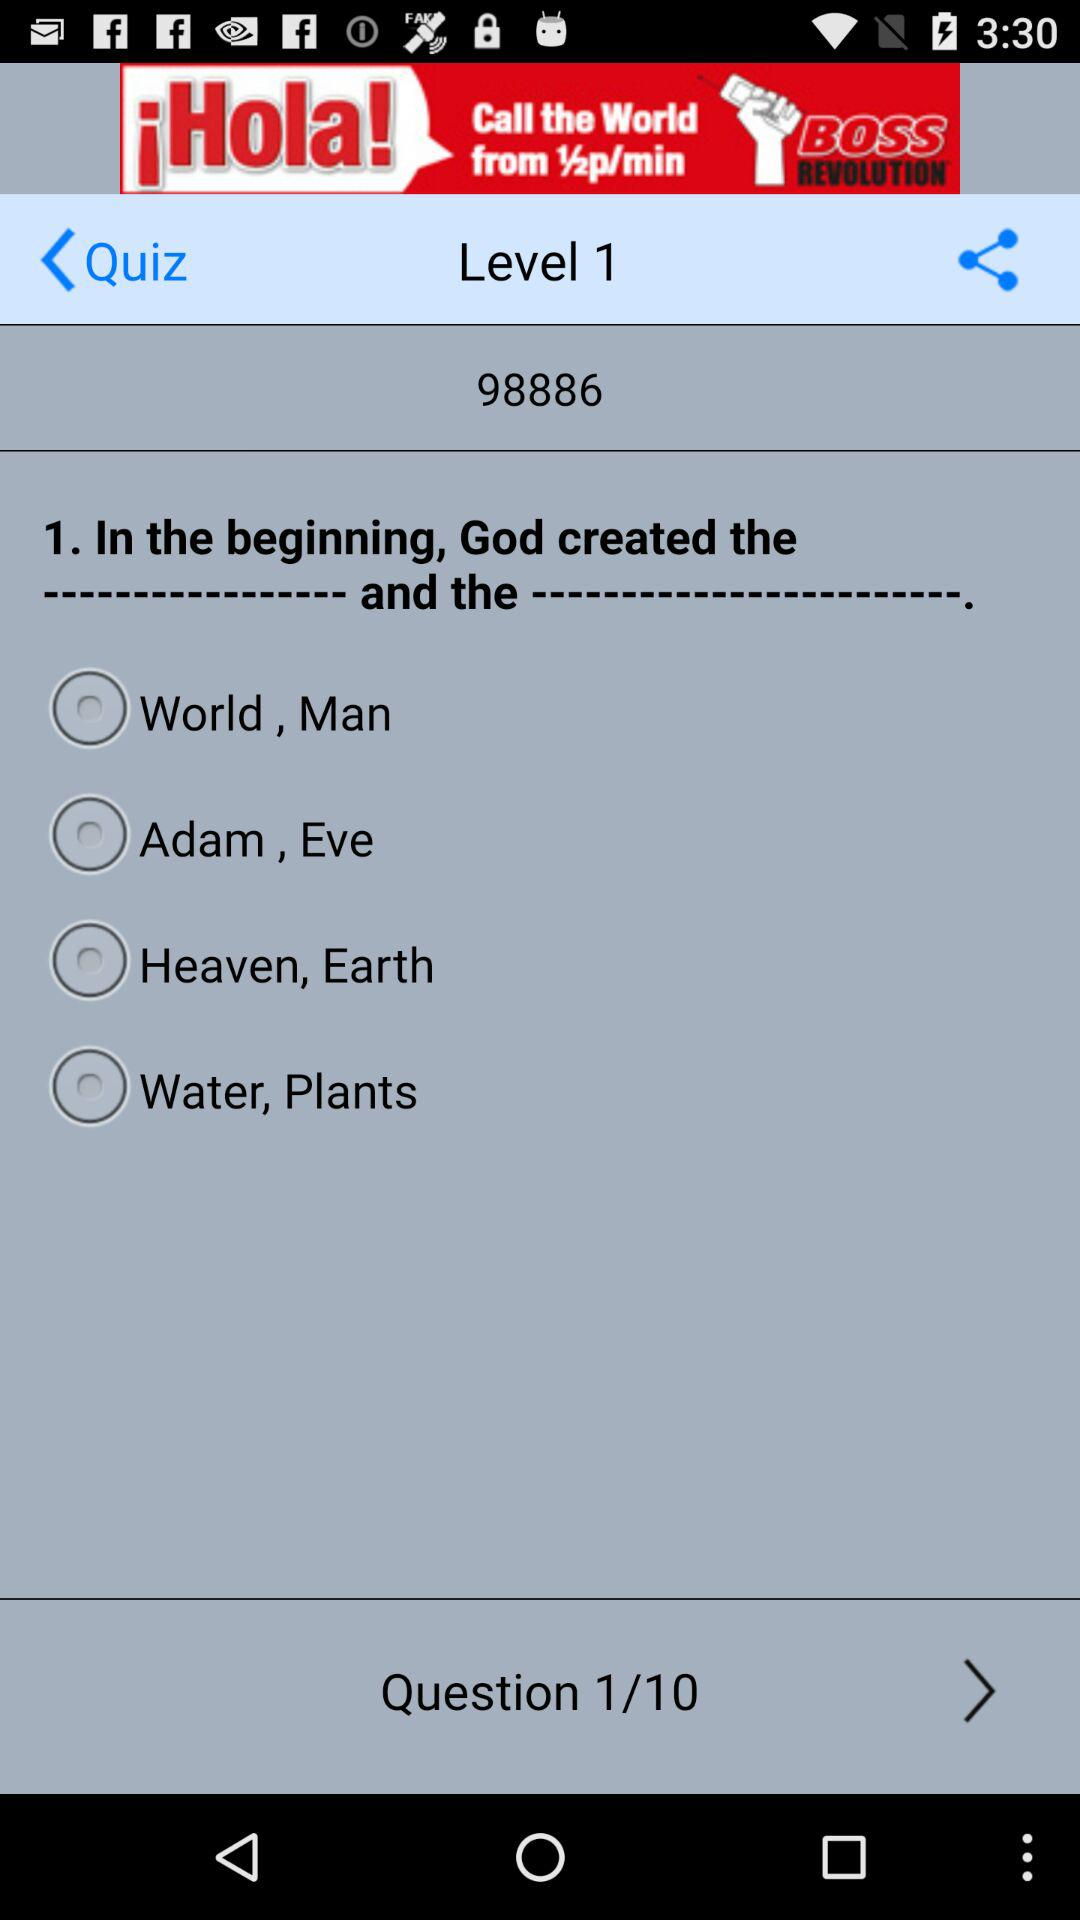How many questions are there?
Answer the question using a single word or phrase. There are 10 questions 